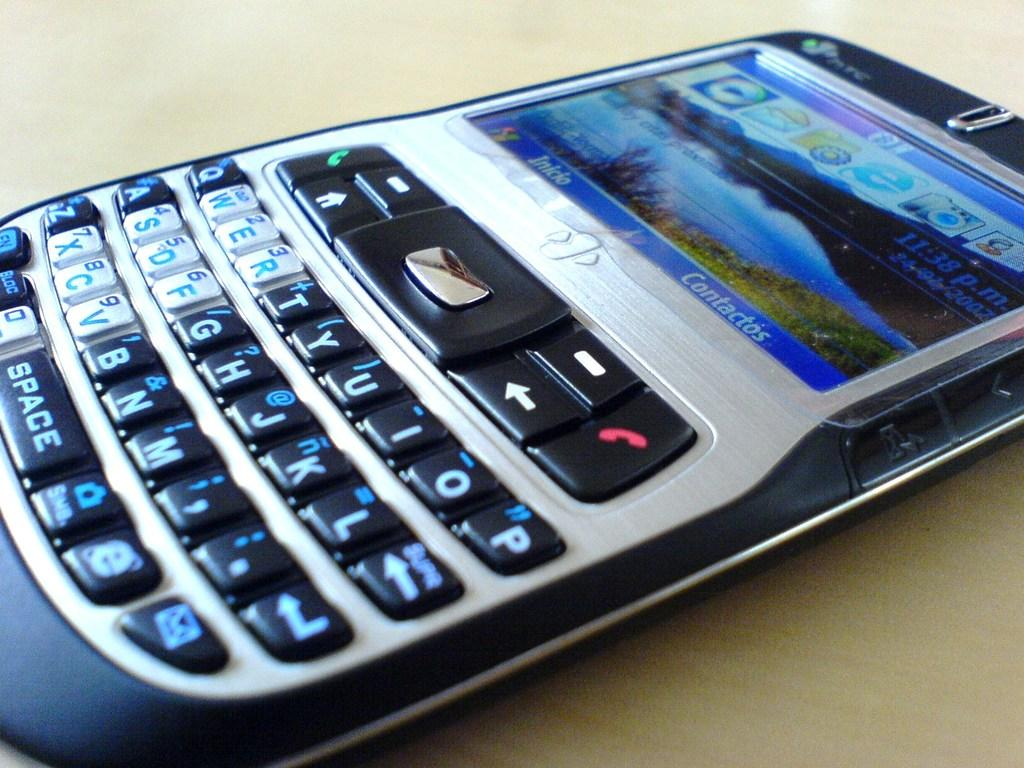<image>
Provide a brief description of the given image. A HTC device sits on the table with its screen illuminated. 